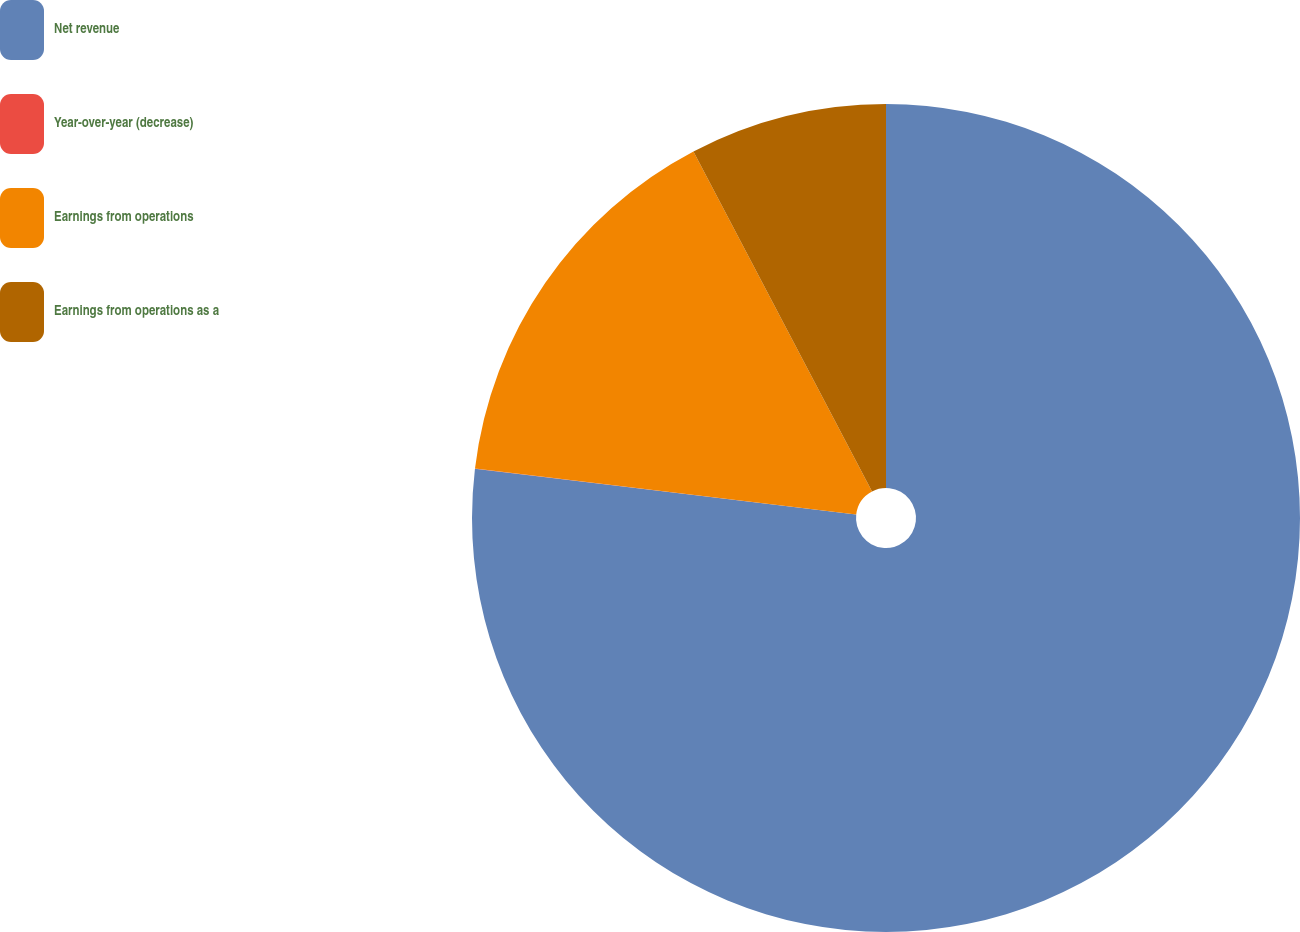<chart> <loc_0><loc_0><loc_500><loc_500><pie_chart><fcel>Net revenue<fcel>Year-over-year (decrease)<fcel>Earnings from operations<fcel>Earnings from operations as a<nl><fcel>76.91%<fcel>0.01%<fcel>15.39%<fcel>7.7%<nl></chart> 